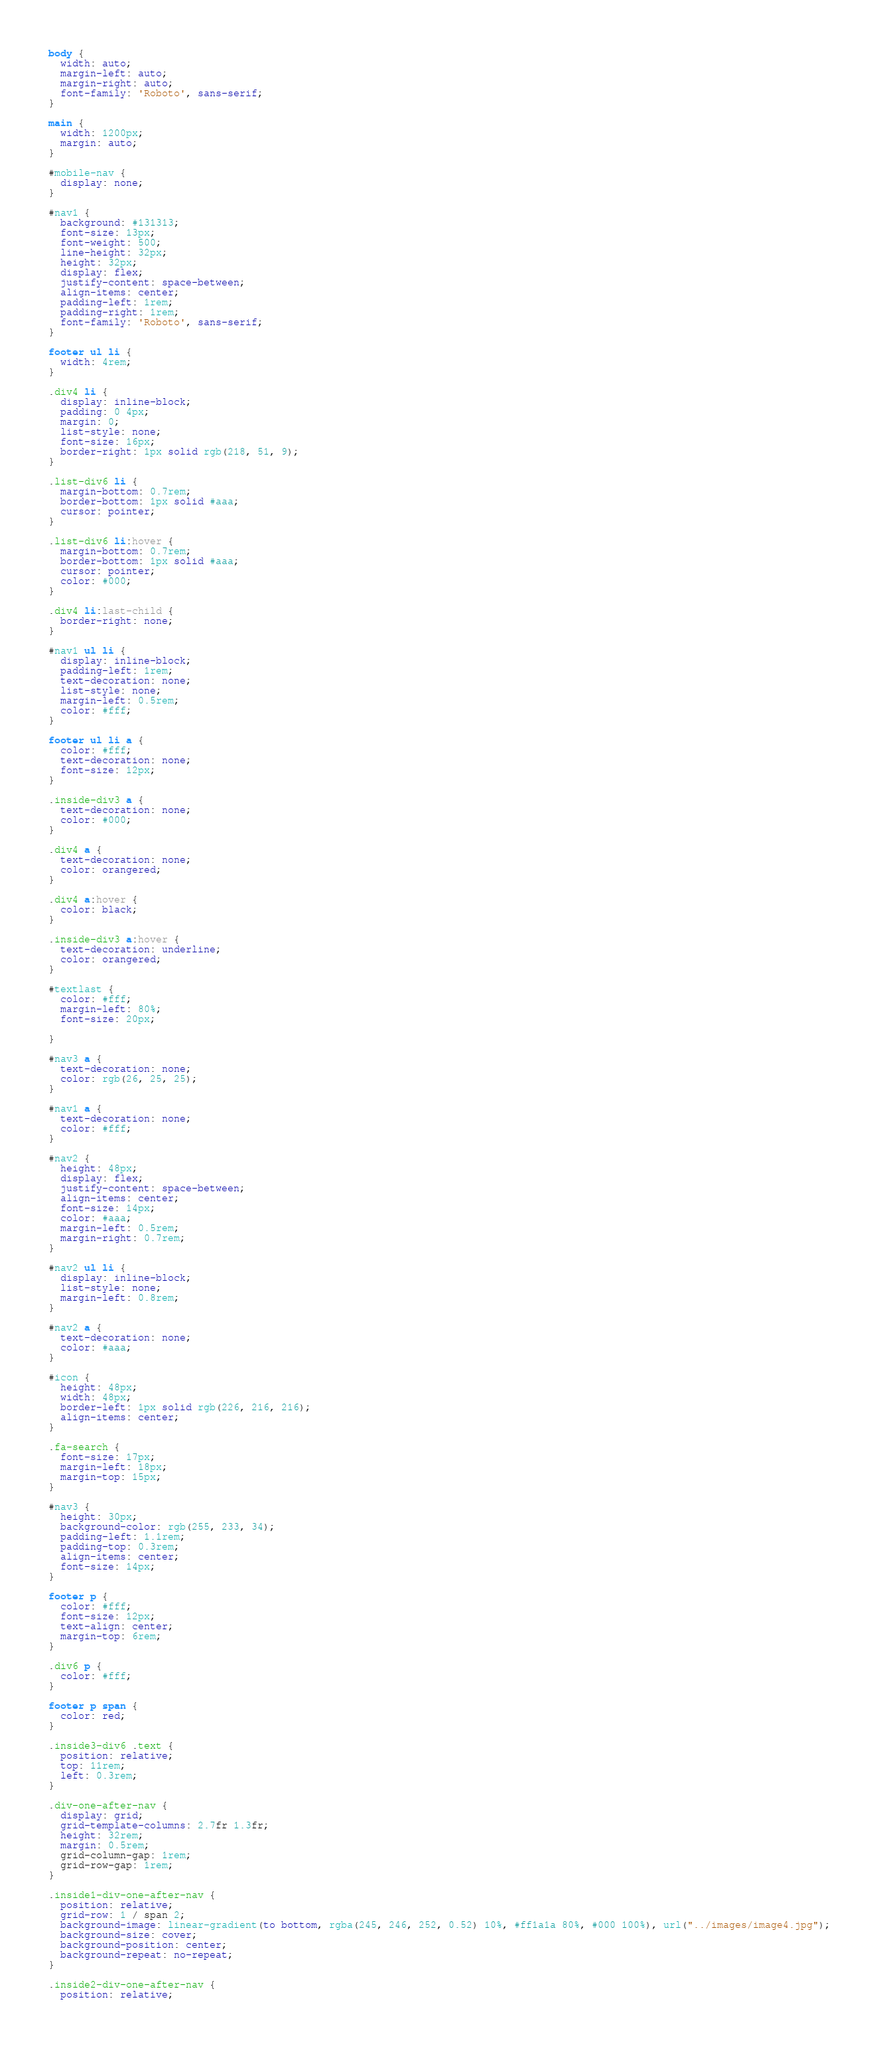<code> <loc_0><loc_0><loc_500><loc_500><_CSS_>body {
  width: auto;
  margin-left: auto;
  margin-right: auto;
  font-family: 'Roboto', sans-serif;
}

main {
  width: 1200px;
  margin: auto;
}

#mobile-nav {
  display: none;
}

#nav1 {
  background: #131313;
  font-size: 13px;
  font-weight: 500;
  line-height: 32px;
  height: 32px;
  display: flex;
  justify-content: space-between;
  align-items: center;
  padding-left: 1rem;
  padding-right: 1rem;
  font-family: 'Roboto', sans-serif;
}

footer ul li {
  width: 4rem;
}

.div4 li {
  display: inline-block;
  padding: 0 4px;
  margin: 0;
  list-style: none;
  font-size: 16px;
  border-right: 1px solid rgb(218, 51, 9);
}

.list-div6 li {
  margin-bottom: 0.7rem;
  border-bottom: 1px solid #aaa;
  cursor: pointer;
}

.list-div6 li:hover {
  margin-bottom: 0.7rem;
  border-bottom: 1px solid #aaa;
  cursor: pointer;
  color: #000;
}

.div4 li:last-child {
  border-right: none;
}

#nav1 ul li {
  display: inline-block;
  padding-left: 1rem;
  text-decoration: none;
  list-style: none;
  margin-left: 0.5rem;
  color: #fff;
}

footer ul li a {
  color: #fff;
  text-decoration: none;
  font-size: 12px;
}

.inside-div3 a {
  text-decoration: none;
  color: #000;
}

.div4 a {
  text-decoration: none;
  color: orangered;
}

.div4 a:hover {
  color: black;
}

.inside-div3 a:hover {
  text-decoration: underline;
  color: orangered;
}

#textlast {
  color: #fff;
  margin-left: 80%;
  font-size: 20px;

}

#nav3 a {
  text-decoration: none;
  color: rgb(26, 25, 25);
}

#nav1 a {
  text-decoration: none;
  color: #fff;
}

#nav2 {
  height: 48px;
  display: flex;
  justify-content: space-between;
  align-items: center;
  font-size: 14px;
  color: #aaa;
  margin-left: 0.5rem;
  margin-right: 0.7rem;
}

#nav2 ul li {
  display: inline-block;
  list-style: none;
  margin-left: 0.8rem;
}

#nav2 a {
  text-decoration: none;
  color: #aaa;
}

#icon {
  height: 48px;
  width: 48px;
  border-left: 1px solid rgb(226, 216, 216);
  align-items: center;
}

.fa-search {
  font-size: 17px;
  margin-left: 18px;
  margin-top: 15px;
}

#nav3 {
  height: 30px;
  background-color: rgb(255, 233, 34);
  padding-left: 1.1rem;
  padding-top: 0.3rem;
  align-items: center;
  font-size: 14px;
}

footer p {
  color: #fff;
  font-size: 12px;
  text-align: center;
  margin-top: 6rem;
}

.div6 p {
  color: #fff;
}

footer p span {
  color: red;
}

.inside3-div6 .text {
  position: relative;
  top: 11rem;
  left: 0.3rem;
}

.div-one-after-nav {
  display: grid;
  grid-template-columns: 2.7fr 1.3fr;
  height: 32rem;
  margin: 0.5rem;
  grid-column-gap: 1rem;
  grid-row-gap: 1rem;
}

.inside1-div-one-after-nav {
  position: relative;
  grid-row: 1 / span 2;
  background-image: linear-gradient(to bottom, rgba(245, 246, 252, 0.52) 10%, #ff1a1a 80%, #000 100%), url("../images/image4.jpg");
  background-size: cover;
  background-position: center;
  background-repeat: no-repeat;
}

.inside2-div-one-after-nav {
  position: relative;</code> 